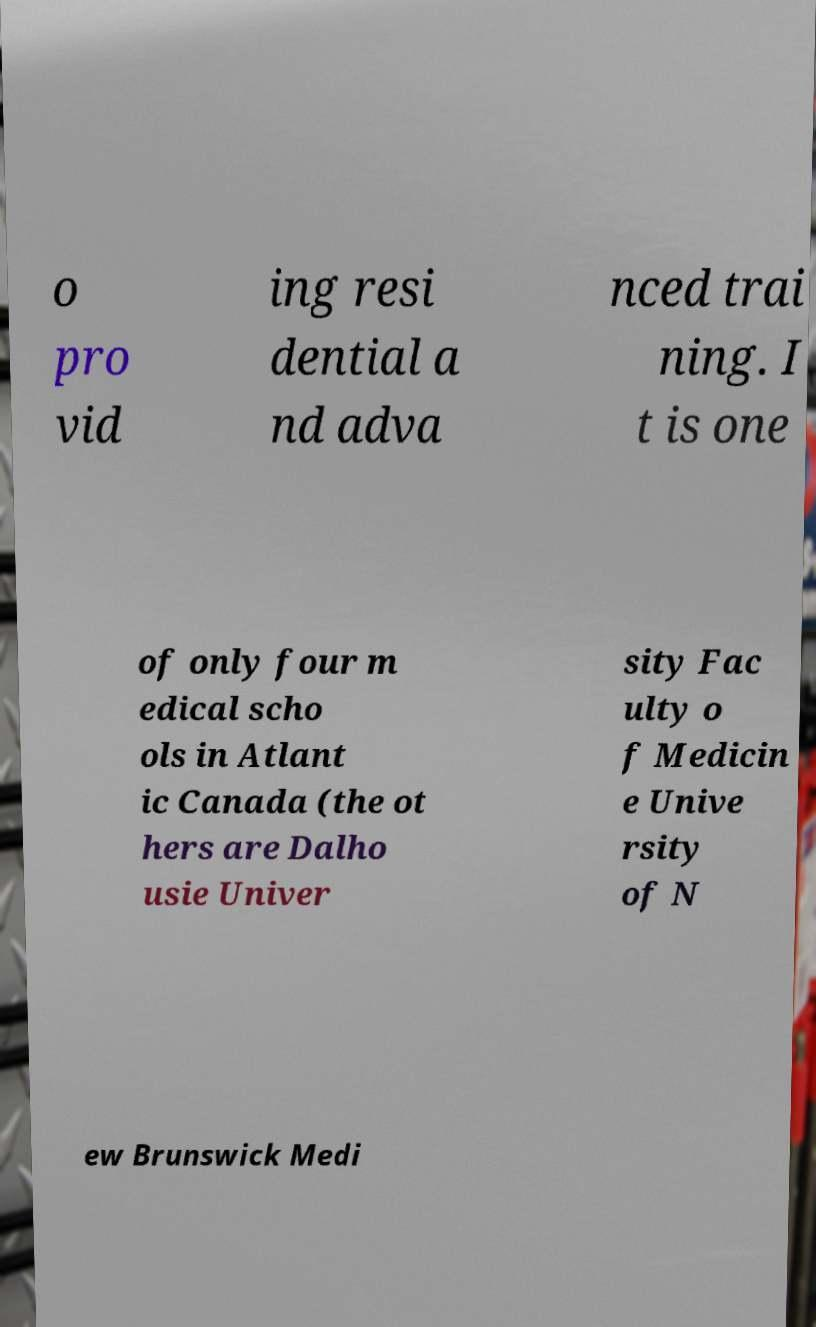Please read and relay the text visible in this image. What does it say? o pro vid ing resi dential a nd adva nced trai ning. I t is one of only four m edical scho ols in Atlant ic Canada (the ot hers are Dalho usie Univer sity Fac ulty o f Medicin e Unive rsity of N ew Brunswick Medi 